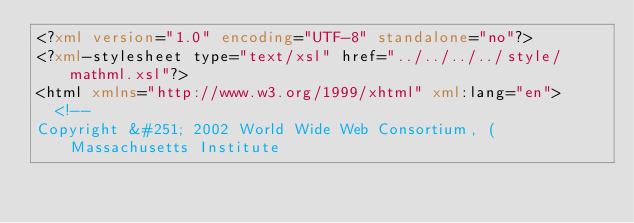<code> <loc_0><loc_0><loc_500><loc_500><_XML_><?xml version="1.0" encoding="UTF-8" standalone="no"?>
<?xml-stylesheet type="text/xsl" href="../../../../style/mathml.xsl"?>
<html xmlns="http://www.w3.org/1999/xhtml" xml:lang="en">
  <!--
Copyright &#251; 2002 World Wide Web Consortium, (Massachusetts Institute</code> 